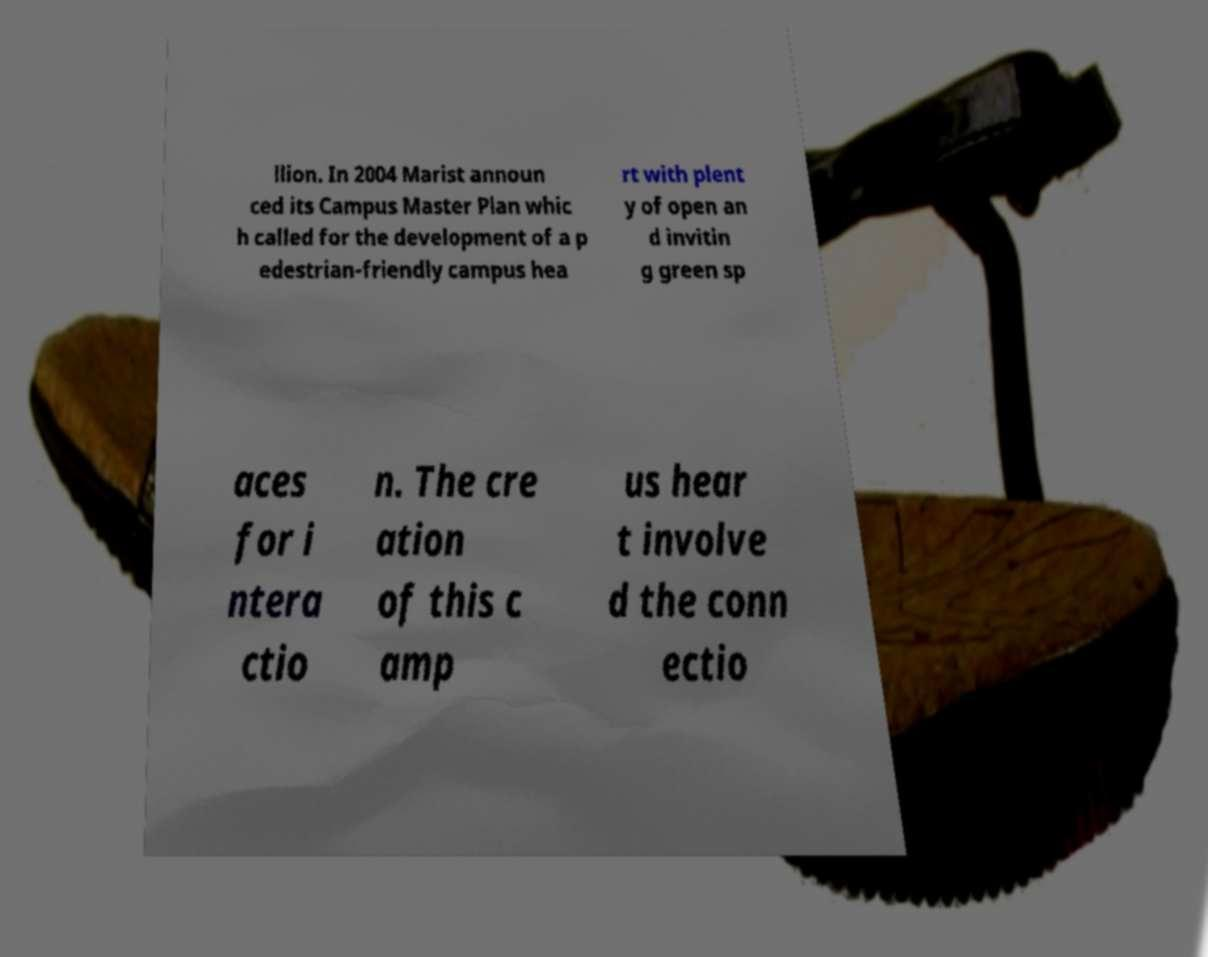For documentation purposes, I need the text within this image transcribed. Could you provide that? llion. In 2004 Marist announ ced its Campus Master Plan whic h called for the development of a p edestrian-friendly campus hea rt with plent y of open an d invitin g green sp aces for i ntera ctio n. The cre ation of this c amp us hear t involve d the conn ectio 